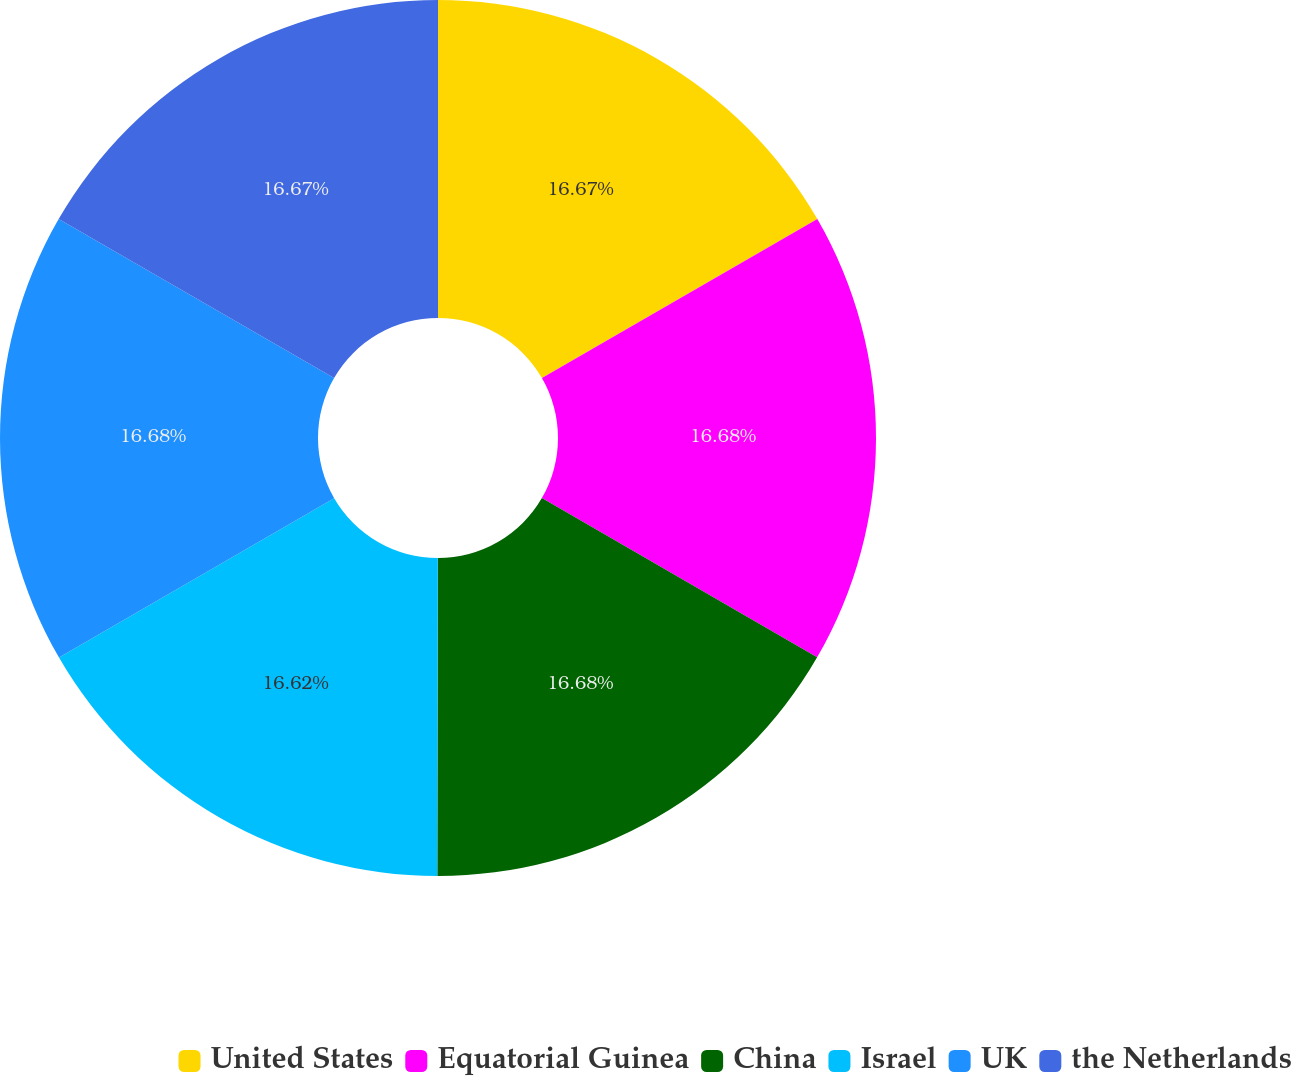<chart> <loc_0><loc_0><loc_500><loc_500><pie_chart><fcel>United States<fcel>Equatorial Guinea<fcel>China<fcel>Israel<fcel>UK<fcel>the Netherlands<nl><fcel>16.67%<fcel>16.68%<fcel>16.68%<fcel>16.62%<fcel>16.69%<fcel>16.67%<nl></chart> 